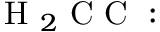Convert formula to latex. <formula><loc_0><loc_0><loc_500><loc_500>H _ { 2 } C C \colon</formula> 